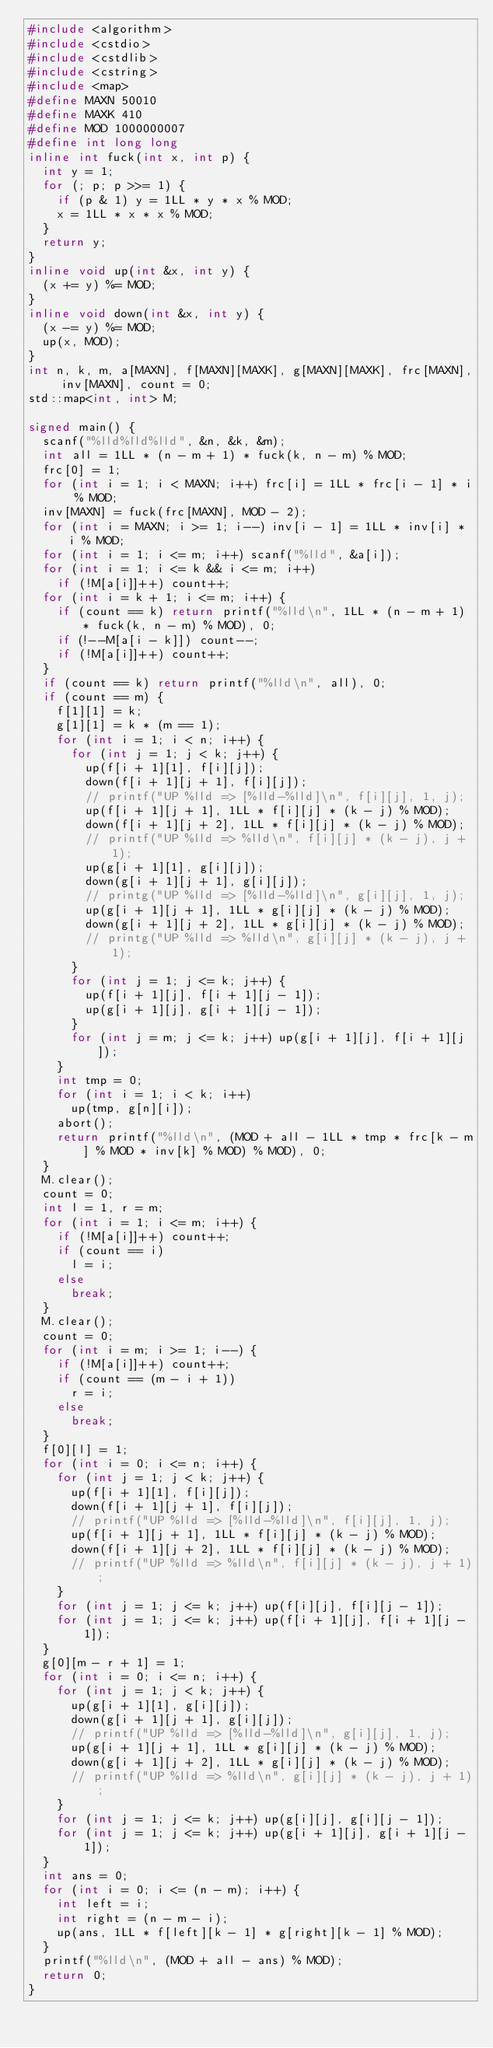<code> <loc_0><loc_0><loc_500><loc_500><_C++_>#include <algorithm>
#include <cstdio>
#include <cstdlib>
#include <cstring>
#include <map>
#define MAXN 50010
#define MAXK 410
#define MOD 1000000007
#define int long long
inline int fuck(int x, int p) {
	int y = 1;
	for (; p; p >>= 1) {
		if (p & 1) y = 1LL * y * x % MOD;
		x = 1LL * x * x % MOD;
	}
	return y;
}
inline void up(int &x, int y) {
	(x += y) %= MOD;
}
inline void down(int &x, int y) {
	(x -= y) %= MOD;
	up(x, MOD);
}
int n, k, m, a[MAXN], f[MAXN][MAXK], g[MAXN][MAXK], frc[MAXN], inv[MAXN], count = 0;
std::map<int, int> M;

signed main() {
	scanf("%lld%lld%lld", &n, &k, &m);
	int all = 1LL * (n - m + 1) * fuck(k, n - m) % MOD;
	frc[0] = 1;
	for (int i = 1; i < MAXN; i++) frc[i] = 1LL * frc[i - 1] * i % MOD;
	inv[MAXN] = fuck(frc[MAXN], MOD - 2);
	for (int i = MAXN; i >= 1; i--) inv[i - 1] = 1LL * inv[i] * i % MOD;
	for (int i = 1; i <= m; i++) scanf("%lld", &a[i]);
	for (int i = 1; i <= k && i <= m; i++)
		if (!M[a[i]]++) count++;
	for (int i = k + 1; i <= m; i++) {
		if (count == k) return printf("%lld\n", 1LL * (n - m + 1) * fuck(k, n - m) % MOD), 0;
		if (!--M[a[i - k]]) count--;
		if (!M[a[i]]++) count++;
	}
	if (count == k) return printf("%lld\n", all), 0;
	if (count == m) {
		f[1][1] = k;
		g[1][1] = k * (m == 1);
		for (int i = 1; i < n; i++) {
			for (int j = 1; j < k; j++) {
				up(f[i + 1][1], f[i][j]);
				down(f[i + 1][j + 1], f[i][j]);
				// printf("UP %lld => [%lld-%lld]\n", f[i][j], 1, j);
				up(f[i + 1][j + 1], 1LL * f[i][j] * (k - j) % MOD);
				down(f[i + 1][j + 2], 1LL * f[i][j] * (k - j) % MOD);
				// printf("UP %lld => %lld\n", f[i][j] * (k - j), j + 1);
				up(g[i + 1][1], g[i][j]);
				down(g[i + 1][j + 1], g[i][j]);
				// printg("UP %lld => [%lld-%lld]\n", g[i][j], 1, j);
				up(g[i + 1][j + 1], 1LL * g[i][j] * (k - j) % MOD);
				down(g[i + 1][j + 2], 1LL * g[i][j] * (k - j) % MOD);
				// printg("UP %lld => %lld\n", g[i][j] * (k - j), j + 1);
			}
			for (int j = 1; j <= k; j++) {
				up(f[i + 1][j], f[i + 1][j - 1]);
				up(g[i + 1][j], g[i + 1][j - 1]);
			}
			for (int j = m; j <= k; j++) up(g[i + 1][j], f[i + 1][j]);
		}
		int tmp = 0;
		for (int i = 1; i < k; i++)
			up(tmp, g[n][i]);
		abort();
		return printf("%lld\n", (MOD + all - 1LL * tmp * frc[k - m] % MOD * inv[k] % MOD) % MOD), 0;
	}
	M.clear();
	count = 0;
	int l = 1, r = m;
	for (int i = 1; i <= m; i++) {
		if (!M[a[i]]++) count++;
		if (count == i)
			l = i;
		else
			break;
	}
	M.clear();
	count = 0;
	for (int i = m; i >= 1; i--) {
		if (!M[a[i]]++) count++;
		if (count == (m - i + 1))
			r = i;
		else
			break;
	}
	f[0][l] = 1;
	for (int i = 0; i <= n; i++) {
		for (int j = 1; j < k; j++) {
			up(f[i + 1][1], f[i][j]);
			down(f[i + 1][j + 1], f[i][j]);
			// printf("UP %lld => [%lld-%lld]\n", f[i][j], 1, j);
			up(f[i + 1][j + 1], 1LL * f[i][j] * (k - j) % MOD);
			down(f[i + 1][j + 2], 1LL * f[i][j] * (k - j) % MOD);
			// printf("UP %lld => %lld\n", f[i][j] * (k - j), j + 1);
		}
		for (int j = 1; j <= k; j++) up(f[i][j], f[i][j - 1]);
		for (int j = 1; j <= k; j++) up(f[i + 1][j], f[i + 1][j - 1]);
	}
	g[0][m - r + 1] = 1;
	for (int i = 0; i <= n; i++) {
		for (int j = 1; j < k; j++) {
			up(g[i + 1][1], g[i][j]);
			down(g[i + 1][j + 1], g[i][j]);
			// printf("UP %lld => [%lld-%lld]\n", g[i][j], 1, j);
			up(g[i + 1][j + 1], 1LL * g[i][j] * (k - j) % MOD);
			down(g[i + 1][j + 2], 1LL * g[i][j] * (k - j) % MOD);
			// printf("UP %lld => %lld\n", g[i][j] * (k - j), j + 1);
		}
		for (int j = 1; j <= k; j++) up(g[i][j], g[i][j - 1]);
		for (int j = 1; j <= k; j++) up(g[i + 1][j], g[i + 1][j - 1]);
	}
	int ans = 0;
	for (int i = 0; i <= (n - m); i++) {
		int left = i;
		int right = (n - m - i);
		up(ans, 1LL * f[left][k - 1] * g[right][k - 1] % MOD);
	}
	printf("%lld\n", (MOD + all - ans) % MOD);
	return 0;
}</code> 